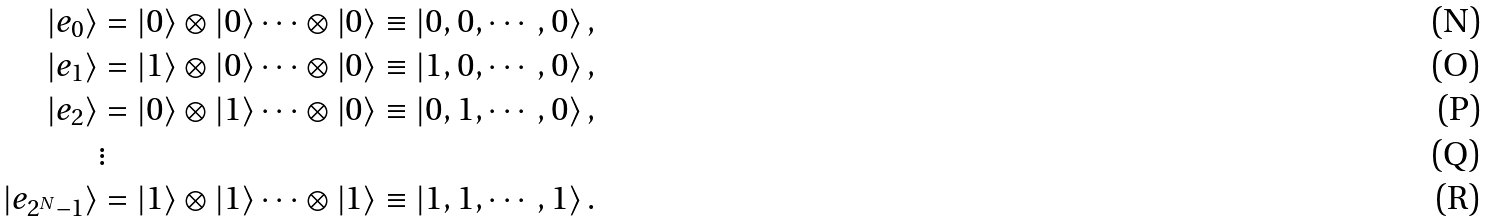Convert formula to latex. <formula><loc_0><loc_0><loc_500><loc_500>\left | e _ { 0 } \right \rangle & = \left | 0 \right \rangle \otimes \left | 0 \right \rangle \cdots \otimes \left | 0 \right \rangle \equiv \left | 0 , 0 , \cdots , 0 \right \rangle , \\ \left | e _ { 1 } \right \rangle & = \left | 1 \right \rangle \otimes \left | 0 \right \rangle \cdots \otimes \left | 0 \right \rangle \equiv \left | 1 , 0 , \cdots , 0 \right \rangle , \\ \left | e _ { 2 } \right \rangle & = \left | 0 \right \rangle \otimes \left | 1 \right \rangle \cdots \otimes \left | 0 \right \rangle \equiv \left | 0 , 1 , \cdots , 0 \right \rangle , \\ & \vdots \\ \left | e _ { 2 ^ { N } - 1 } \right \rangle & = \left | 1 \right \rangle \otimes \left | 1 \right \rangle \cdots \otimes \left | 1 \right \rangle \equiv \left | 1 , 1 , \cdots , 1 \right \rangle .</formula> 